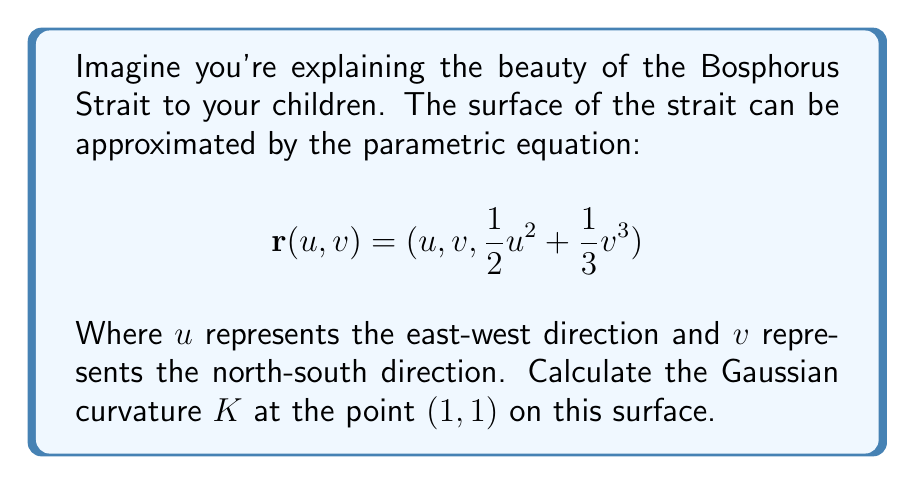Give your solution to this math problem. To find the Gaussian curvature, we need to follow these steps:

1) First, calculate the partial derivatives:
   $$\mathbf{r}_u = (1, 0, u)$$
   $$\mathbf{r}_v = (0, 1, v^2)$$
   $$\mathbf{r}_{uu} = (0, 0, 1)$$
   $$\mathbf{r}_{uv} = (0, 0, 0)$$
   $$\mathbf{r}_{vv} = (0, 0, 2v)$$

2) Calculate the normal vector:
   $$\mathbf{N} = \frac{\mathbf{r}_u \times \mathbf{r}_v}{|\mathbf{r}_u \times \mathbf{r}_v|} = \frac{(-u, -v^2, 1)}{\sqrt{u^2 + v^4 + 1}}$$

3) Calculate the coefficients of the first fundamental form:
   $$E = \mathbf{r}_u \cdot \mathbf{r}_u = 1 + u^2$$
   $$F = \mathbf{r}_u \cdot \mathbf{r}_v = 0$$
   $$G = \mathbf{r}_v \cdot \mathbf{r}_v = 1 + v^4$$

4) Calculate the coefficients of the second fundamental form:
   $$e = \mathbf{r}_{uu} \cdot \mathbf{N} = \frac{1}{\sqrt{u^2 + v^4 + 1}}$$
   $$f = \mathbf{r}_{uv} \cdot \mathbf{N} = 0$$
   $$g = \mathbf{r}_{vv} \cdot \mathbf{N} = \frac{2v}{\sqrt{u^2 + v^4 + 1}}$$

5) The Gaussian curvature is given by:
   $$K = \frac{eg - f^2}{EG - F^2}$$

6) Substitute the values at point (1,1):
   $$K = \frac{(\frac{1}{\sqrt{3}})(\frac{2}{\sqrt{3}}) - 0^2}{(2)(2) - 0^2} = \frac{2/3}{4} = \frac{1}{6}$$

Therefore, the Gaussian curvature at point (1,1) is $\frac{1}{6}$.
Answer: $K = \frac{1}{6}$ 